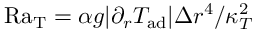Convert formula to latex. <formula><loc_0><loc_0><loc_500><loc_500>R a _ { T } = \alpha g | \partial _ { r } T _ { a d } | \Delta r ^ { 4 } / \kappa _ { T } ^ { 2 }</formula> 